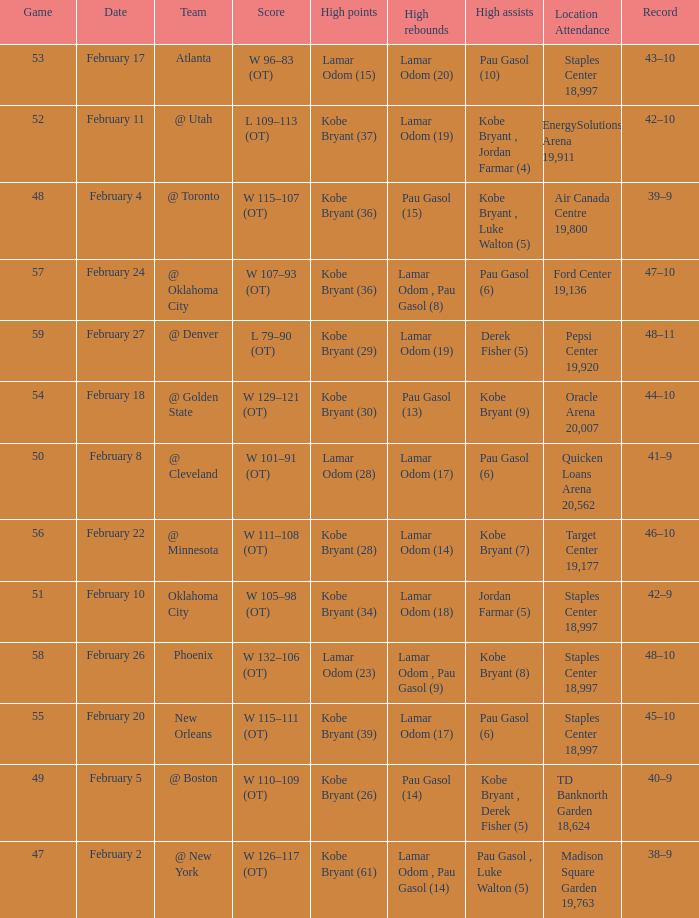Who had the most assists in the game against Atlanta? Pau Gasol (10). 